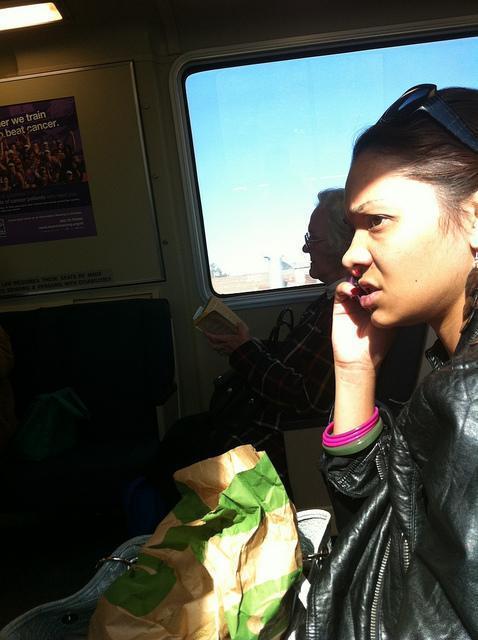How many handbags are visible?
Give a very brief answer. 2. How many people are there?
Give a very brief answer. 2. How many bears are there?
Give a very brief answer. 0. 